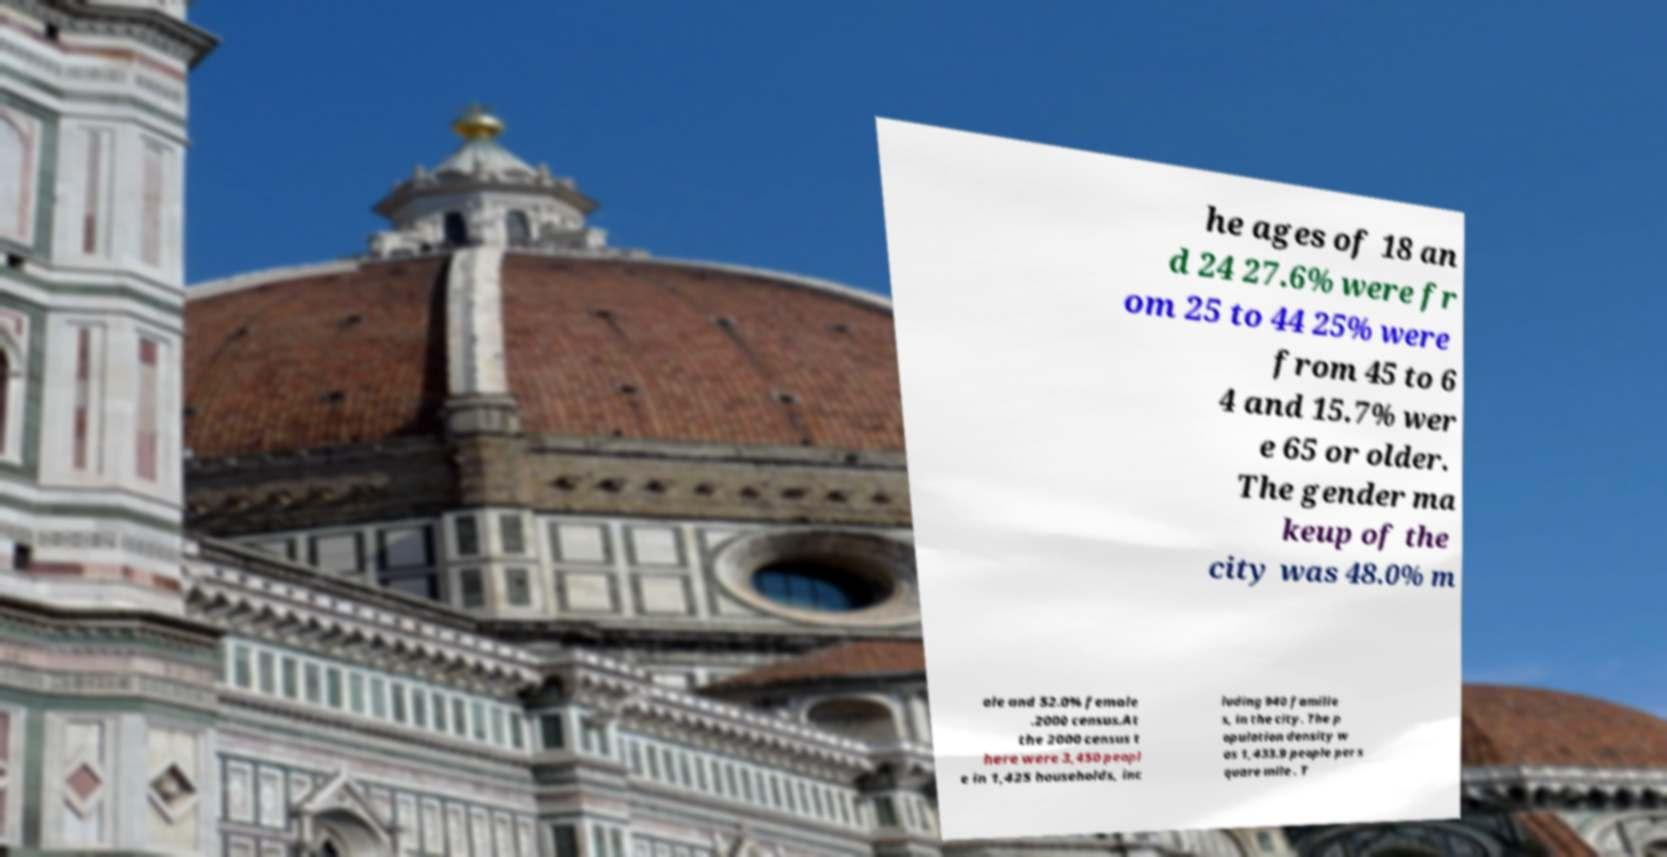What messages or text are displayed in this image? I need them in a readable, typed format. he ages of 18 an d 24 27.6% were fr om 25 to 44 25% were from 45 to 6 4 and 15.7% wer e 65 or older. The gender ma keup of the city was 48.0% m ale and 52.0% female .2000 census.At the 2000 census t here were 3,450 peopl e in 1,425 households, inc luding 940 familie s, in the city. The p opulation density w as 1,433.9 people per s quare mile . T 